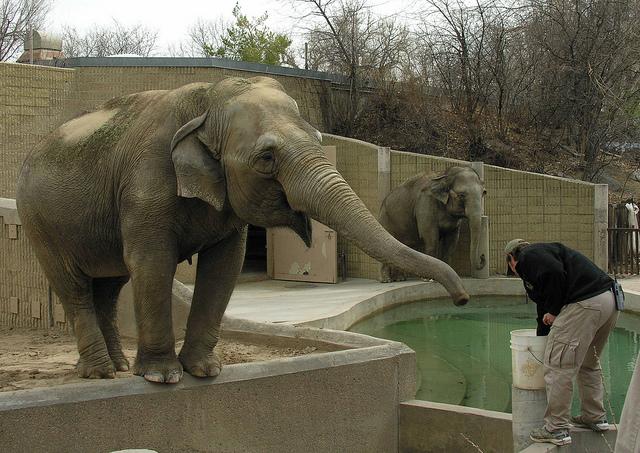What color is the bucket?
Be succinct. White. Is the elephant hungry?
Be succinct. Yes. What color is the water?
Quick response, please. Green. 